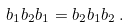Convert formula to latex. <formula><loc_0><loc_0><loc_500><loc_500>b _ { 1 } b _ { 2 } b _ { 1 } = b _ { 2 } b _ { 1 } b _ { 2 } \, . \</formula> 